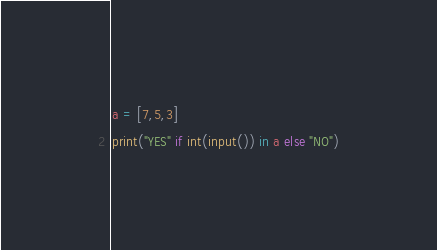Convert code to text. <code><loc_0><loc_0><loc_500><loc_500><_Python_>a = [7,5,3]
print("YES" if int(input()) in a else "NO")</code> 